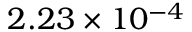Convert formula to latex. <formula><loc_0><loc_0><loc_500><loc_500>2 . 2 3 \times 1 0 ^ { - 4 }</formula> 